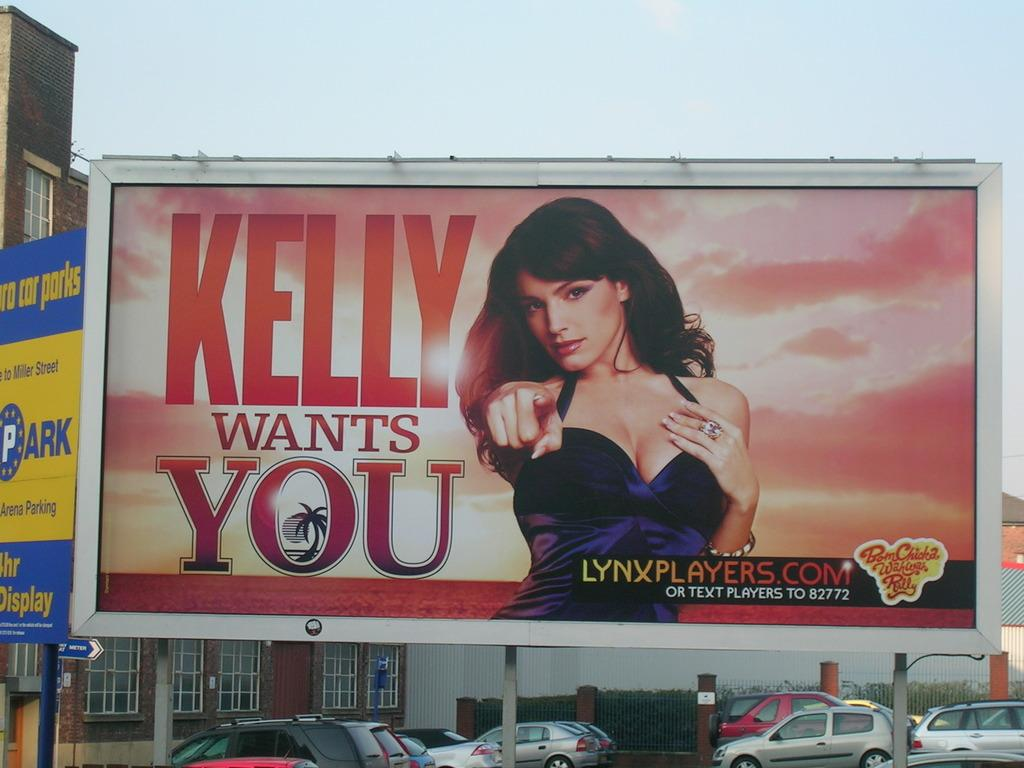<image>
Describe the image concisely. Kelly Wants you banner with a lynxplayers.com website on the bottom right. 